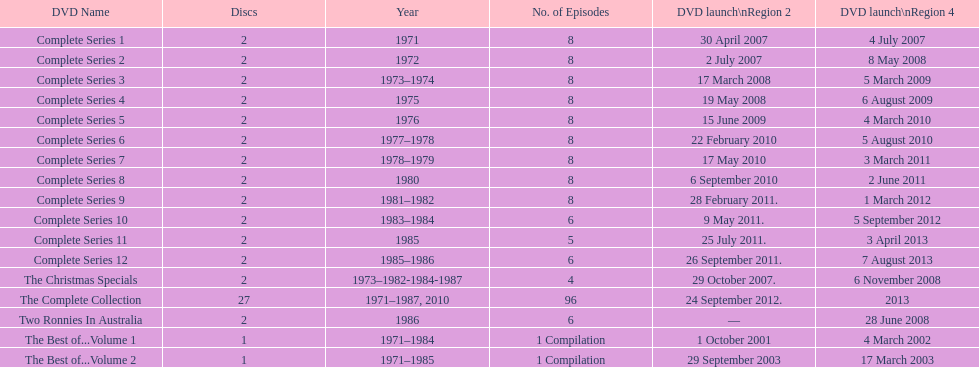How many series had 8 episodes? 9. 